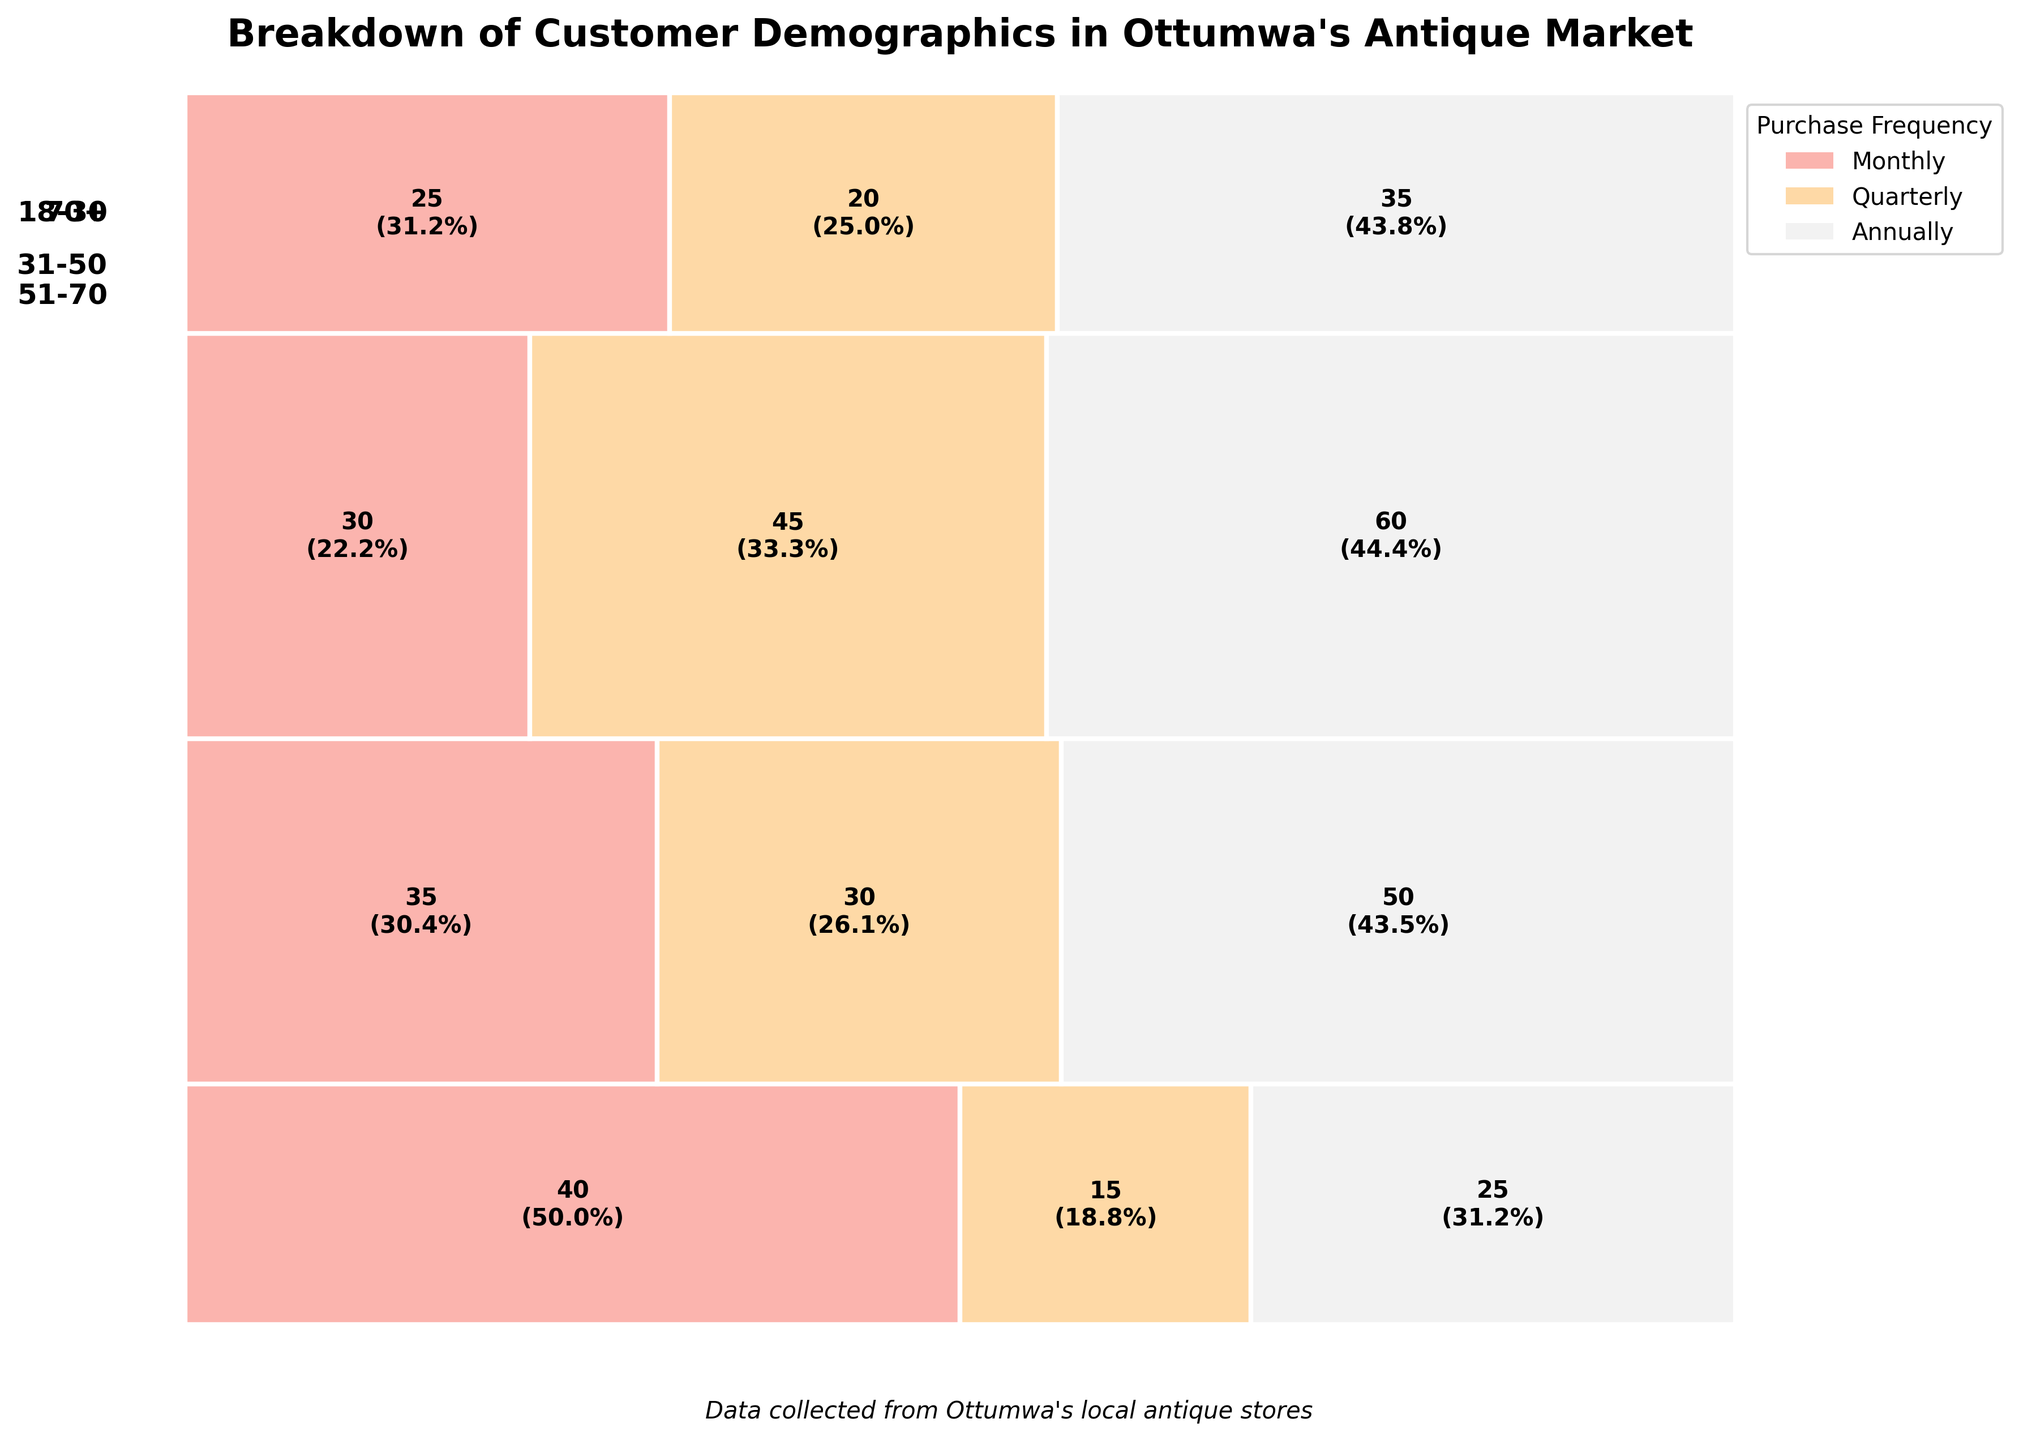What is the title of the mosaic plot? The title of the mosaic plot is written at the top of the figure, providing a brief description of what the data in the plot represents.
Answer: Breakdown of Customer Demographics in Ottumwa's Antique Market Which age group has the highest frequency of monthly purchases? To find the age group with the highest frequency of monthly purchases, locate the tallest bar section within the "Monthly" category.
Answer: 51-70 How many individuals aged 18-30 purchase antiques annually? Look at the section labeled "18-30" and find the corresponding segment for "Annually". The number written in this segment is the count of individuals.
Answer: 40 What is the percentage of quarterly purchases made by the 31-50 age group? Identify the segment for "Quarterly" within the "31-50" age group. The percentage is written inside this section.
Answer: 43.9% How does the purchase frequency for the age group 70+ compare between monthly and quarterly? Locate the sections for "Monthly" and "Quarterly" within the "70+" group. Compare the heights of these sections to determine which is larger.
Answer: Quarterly is higher Which age group has the smallest proportion of annual purchases? Identify the segments for "Annually" in all age groups and compare their sizes. The age group with the smallest segment has the smallest proportion of annual purchases.
Answer: 51-70 What is the total number of monthly purchases across all age groups? Add up the values from the "Monthly" segments in all age groups: 15 (18-30) + 30 (31-50) + 45 (51-70) + 20 (70+).
Answer: 110 Is the number of quarterly purchases higher in the 51-70 age group or the 31-50 age group? Compare the heights of the "Quarterly" segments for both the "51-70" and "31-50" age groups to see which is larger.
Answer: 51-70 is higher What is the median number of purchases for the 18-30 age group across all frequencies? The counts for the "18-30" age group are 15 (Monthly), 25 (Quarterly), and 40 (Annually). Arrange these in ascending order and find the middle value.
Answer: 25 